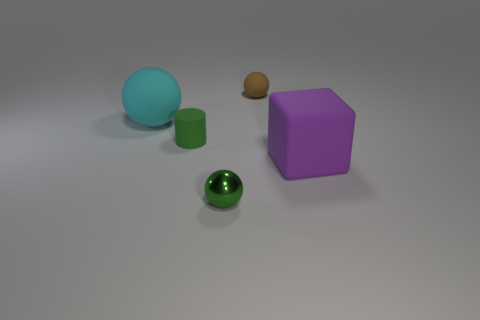Subtract all purple balls. Subtract all gray cylinders. How many balls are left? 3 Add 3 small green rubber cylinders. How many objects exist? 8 Subtract all balls. How many objects are left? 2 Subtract all cyan spheres. Subtract all big cyan things. How many objects are left? 3 Add 2 tiny green objects. How many tiny green objects are left? 4 Add 5 green rubber things. How many green rubber things exist? 6 Subtract 1 purple cubes. How many objects are left? 4 